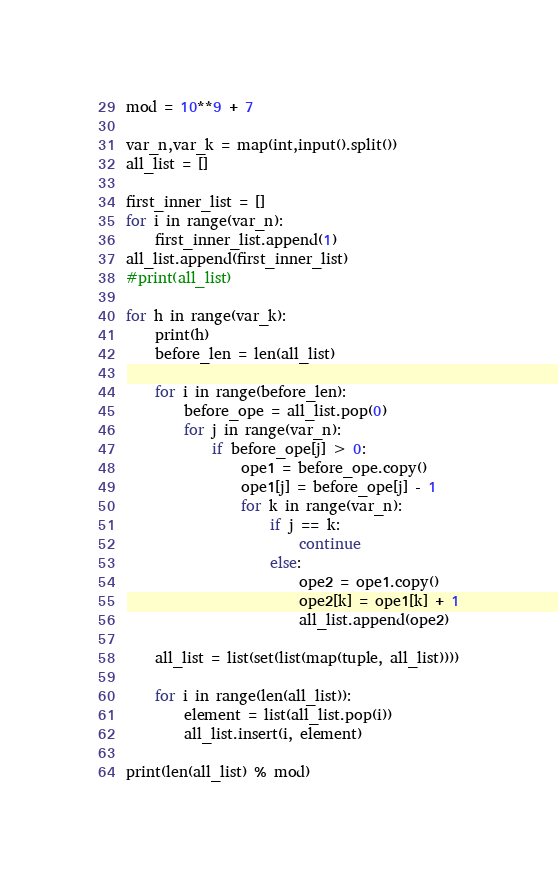Convert code to text. <code><loc_0><loc_0><loc_500><loc_500><_Python_>mod = 10**9 + 7

var_n,var_k = map(int,input().split())
all_list = []

first_inner_list = []
for i in range(var_n):
    first_inner_list.append(1)
all_list.append(first_inner_list)
#print(all_list)

for h in range(var_k):
    print(h)
    before_len = len(all_list)

    for i in range(before_len):
        before_ope = all_list.pop(0)
        for j in range(var_n):
            if before_ope[j] > 0:
                ope1 = before_ope.copy()
                ope1[j] = before_ope[j] - 1
                for k in range(var_n):
                    if j == k:
                        continue
                    else:
                        ope2 = ope1.copy()
                        ope2[k] = ope1[k] + 1
                        all_list.append(ope2)
    
    all_list = list(set(list(map(tuple, all_list))))
    
    for i in range(len(all_list)):
        element = list(all_list.pop(i))
        all_list.insert(i, element)

print(len(all_list) % mod)</code> 